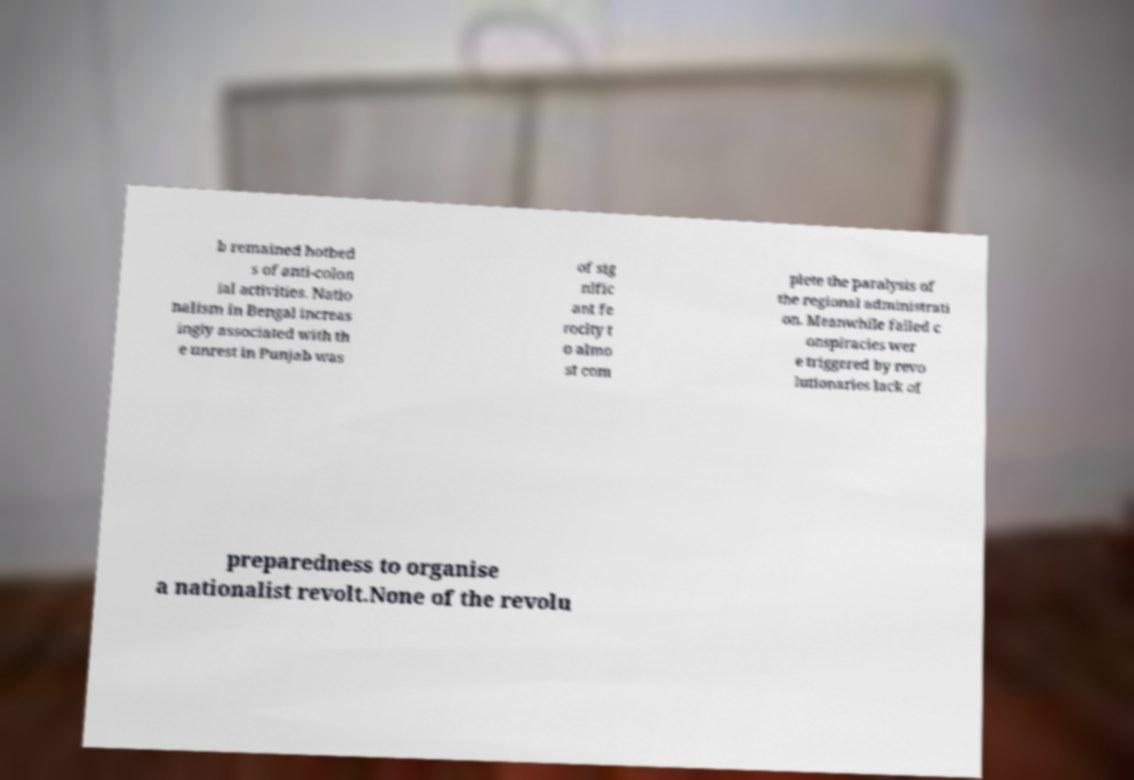Could you assist in decoding the text presented in this image and type it out clearly? b remained hotbed s of anti-colon ial activities. Natio nalism in Bengal increas ingly associated with th e unrest in Punjab was of sig nific ant fe rocity t o almo st com plete the paralysis of the regional administrati on. Meanwhile failed c onspiracies wer e triggered by revo lutionaries lack of preparedness to organise a nationalist revolt.None of the revolu 